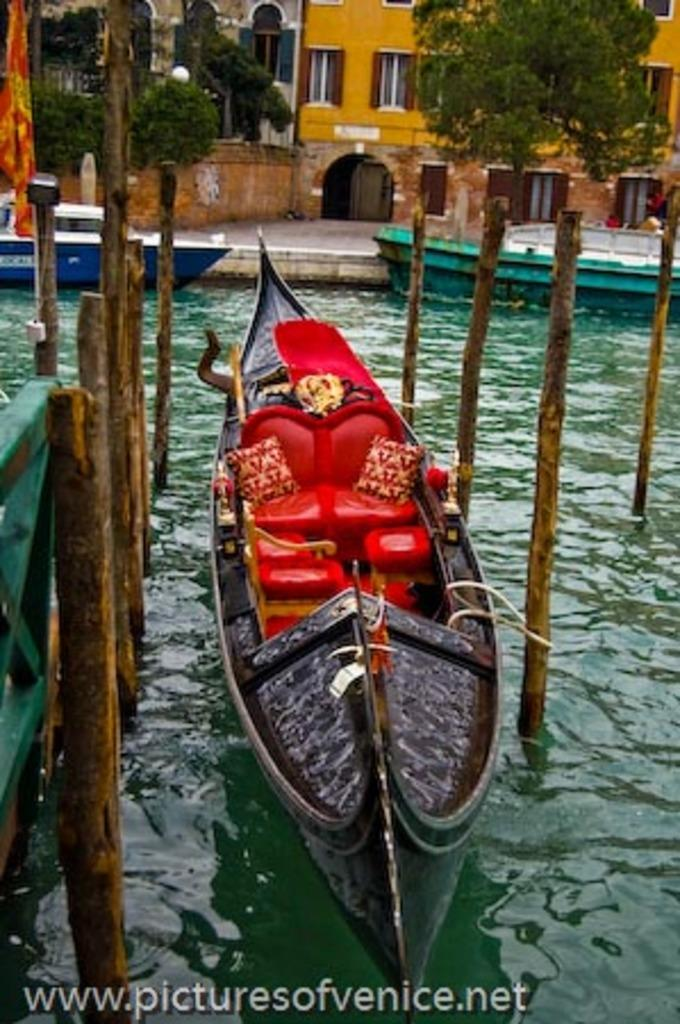What type of vehicles are in the image? There are boats in the image. Where are the boats located? The boats are in a river. What other objects can be seen in the image? There are wooden poles visible in the image. What can be seen in the background of the image? There are trees and buildings in the background of the image. How many pigs are sitting on the boats in the image? There are no pigs present in the image; it features boats in a river with wooden poles and a background of trees and buildings. 